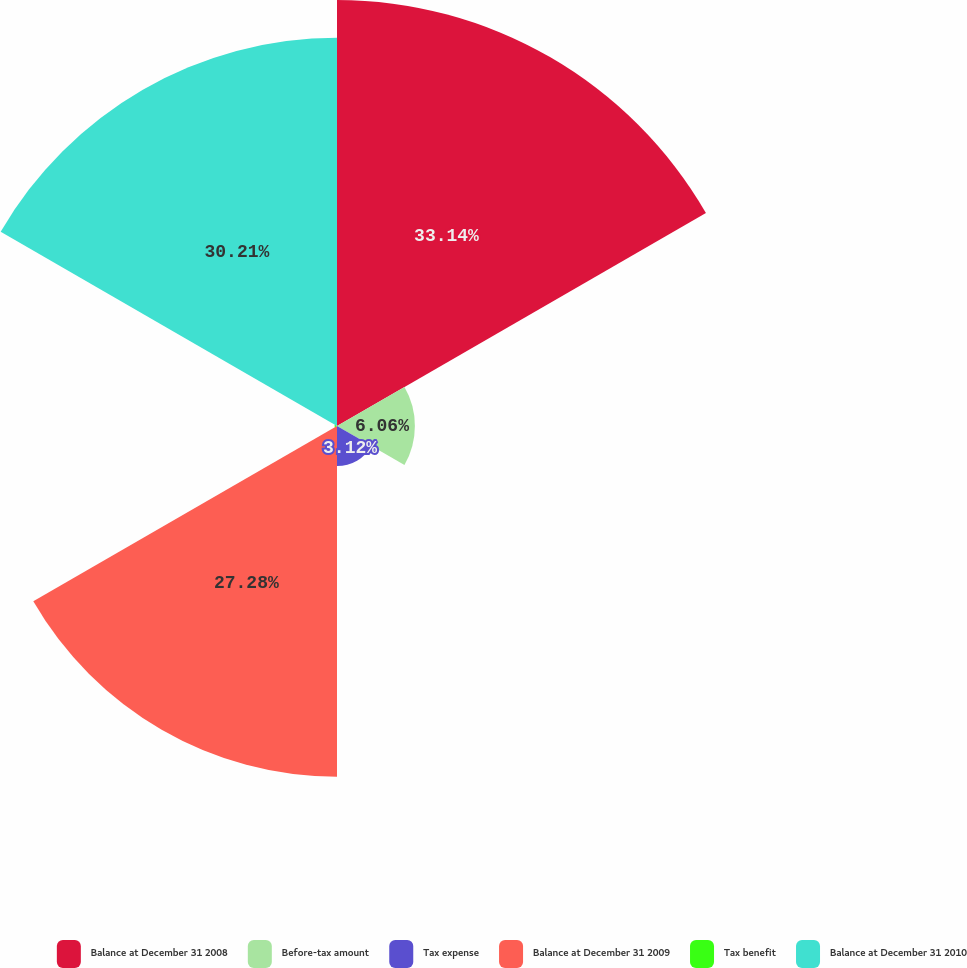<chart> <loc_0><loc_0><loc_500><loc_500><pie_chart><fcel>Balance at December 31 2008<fcel>Before-tax amount<fcel>Tax expense<fcel>Balance at December 31 2009<fcel>Tax benefit<fcel>Balance at December 31 2010<nl><fcel>33.14%<fcel>6.06%<fcel>3.12%<fcel>27.28%<fcel>0.19%<fcel>30.21%<nl></chart> 